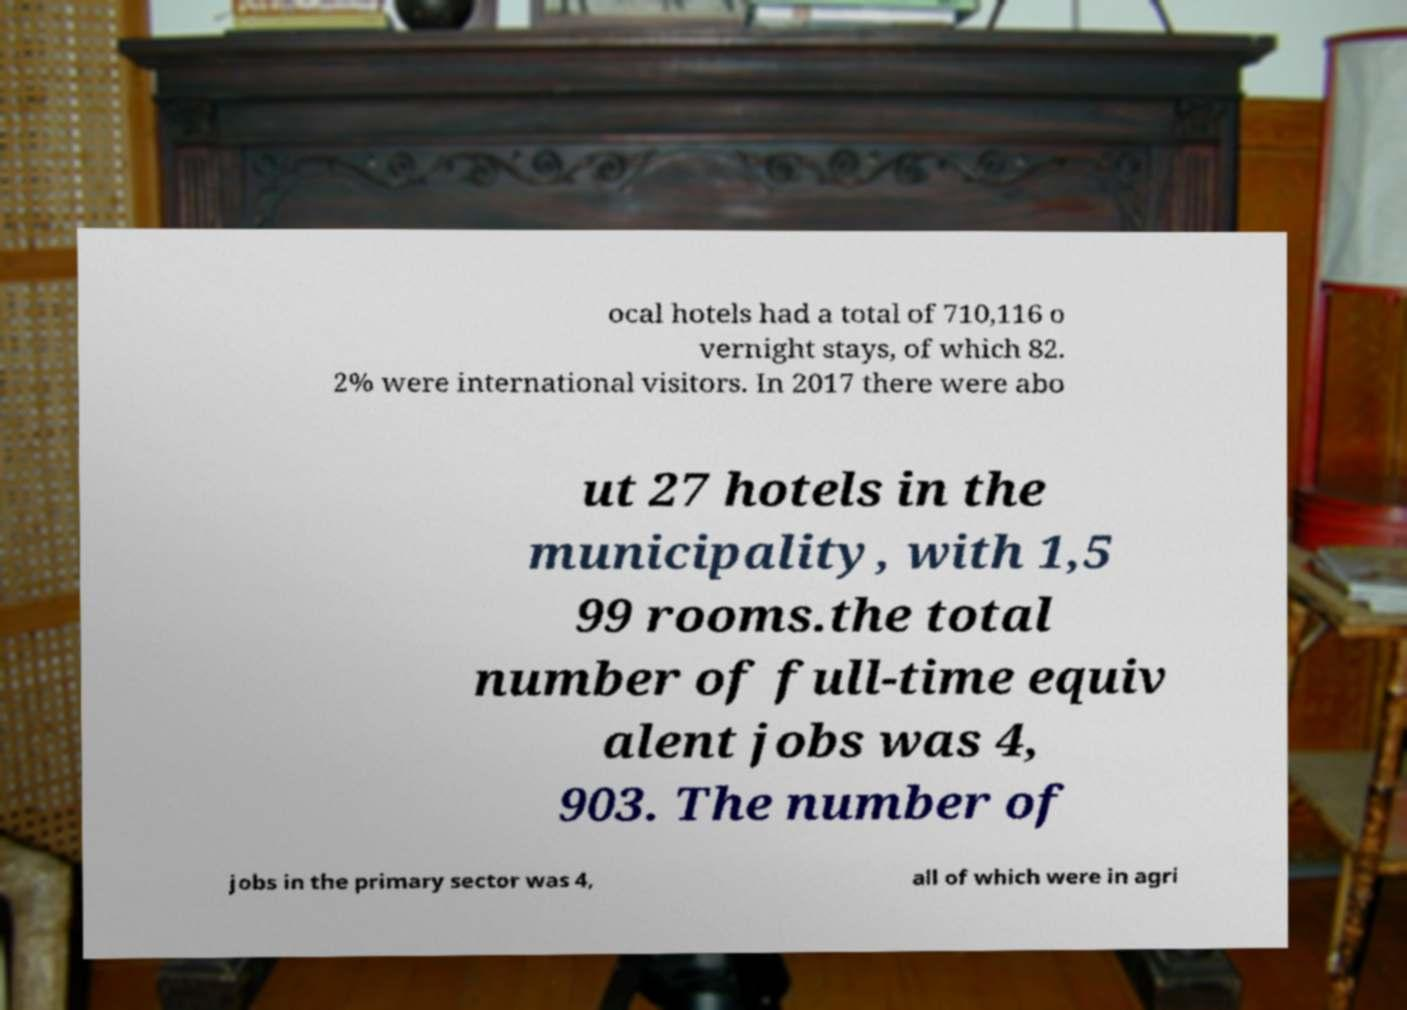What messages or text are displayed in this image? I need them in a readable, typed format. ocal hotels had a total of 710,116 o vernight stays, of which 82. 2% were international visitors. In 2017 there were abo ut 27 hotels in the municipality, with 1,5 99 rooms.the total number of full-time equiv alent jobs was 4, 903. The number of jobs in the primary sector was 4, all of which were in agri 